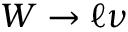<formula> <loc_0><loc_0><loc_500><loc_500>W \to \ell \nu</formula> 